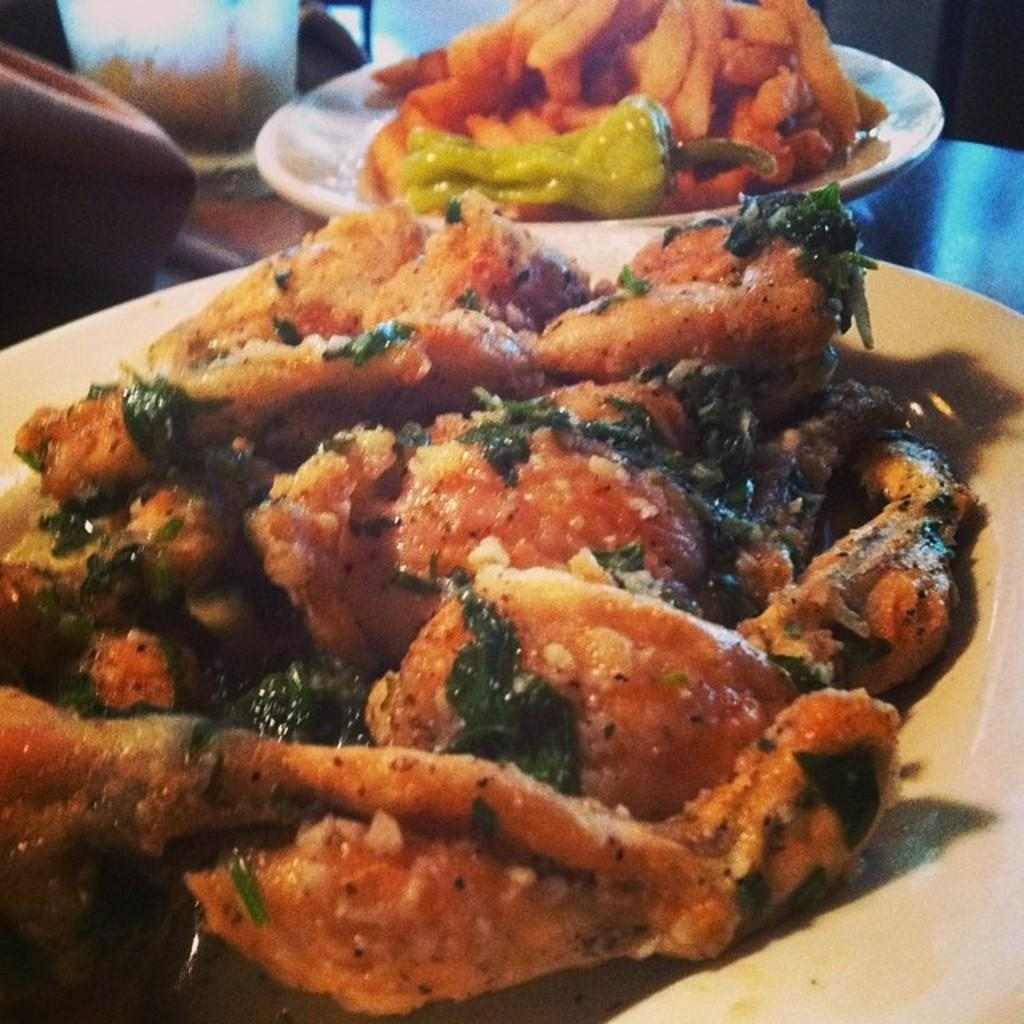What can be seen on the plates in the image? There are food items on plates in the image. Can you describe the other items visible in the image? There are other items on an object in the image, but the specific items are not mentioned in the provided facts. What is the price of the dock in the image? There is no dock present in the image, so it is not possible to determine the price. 